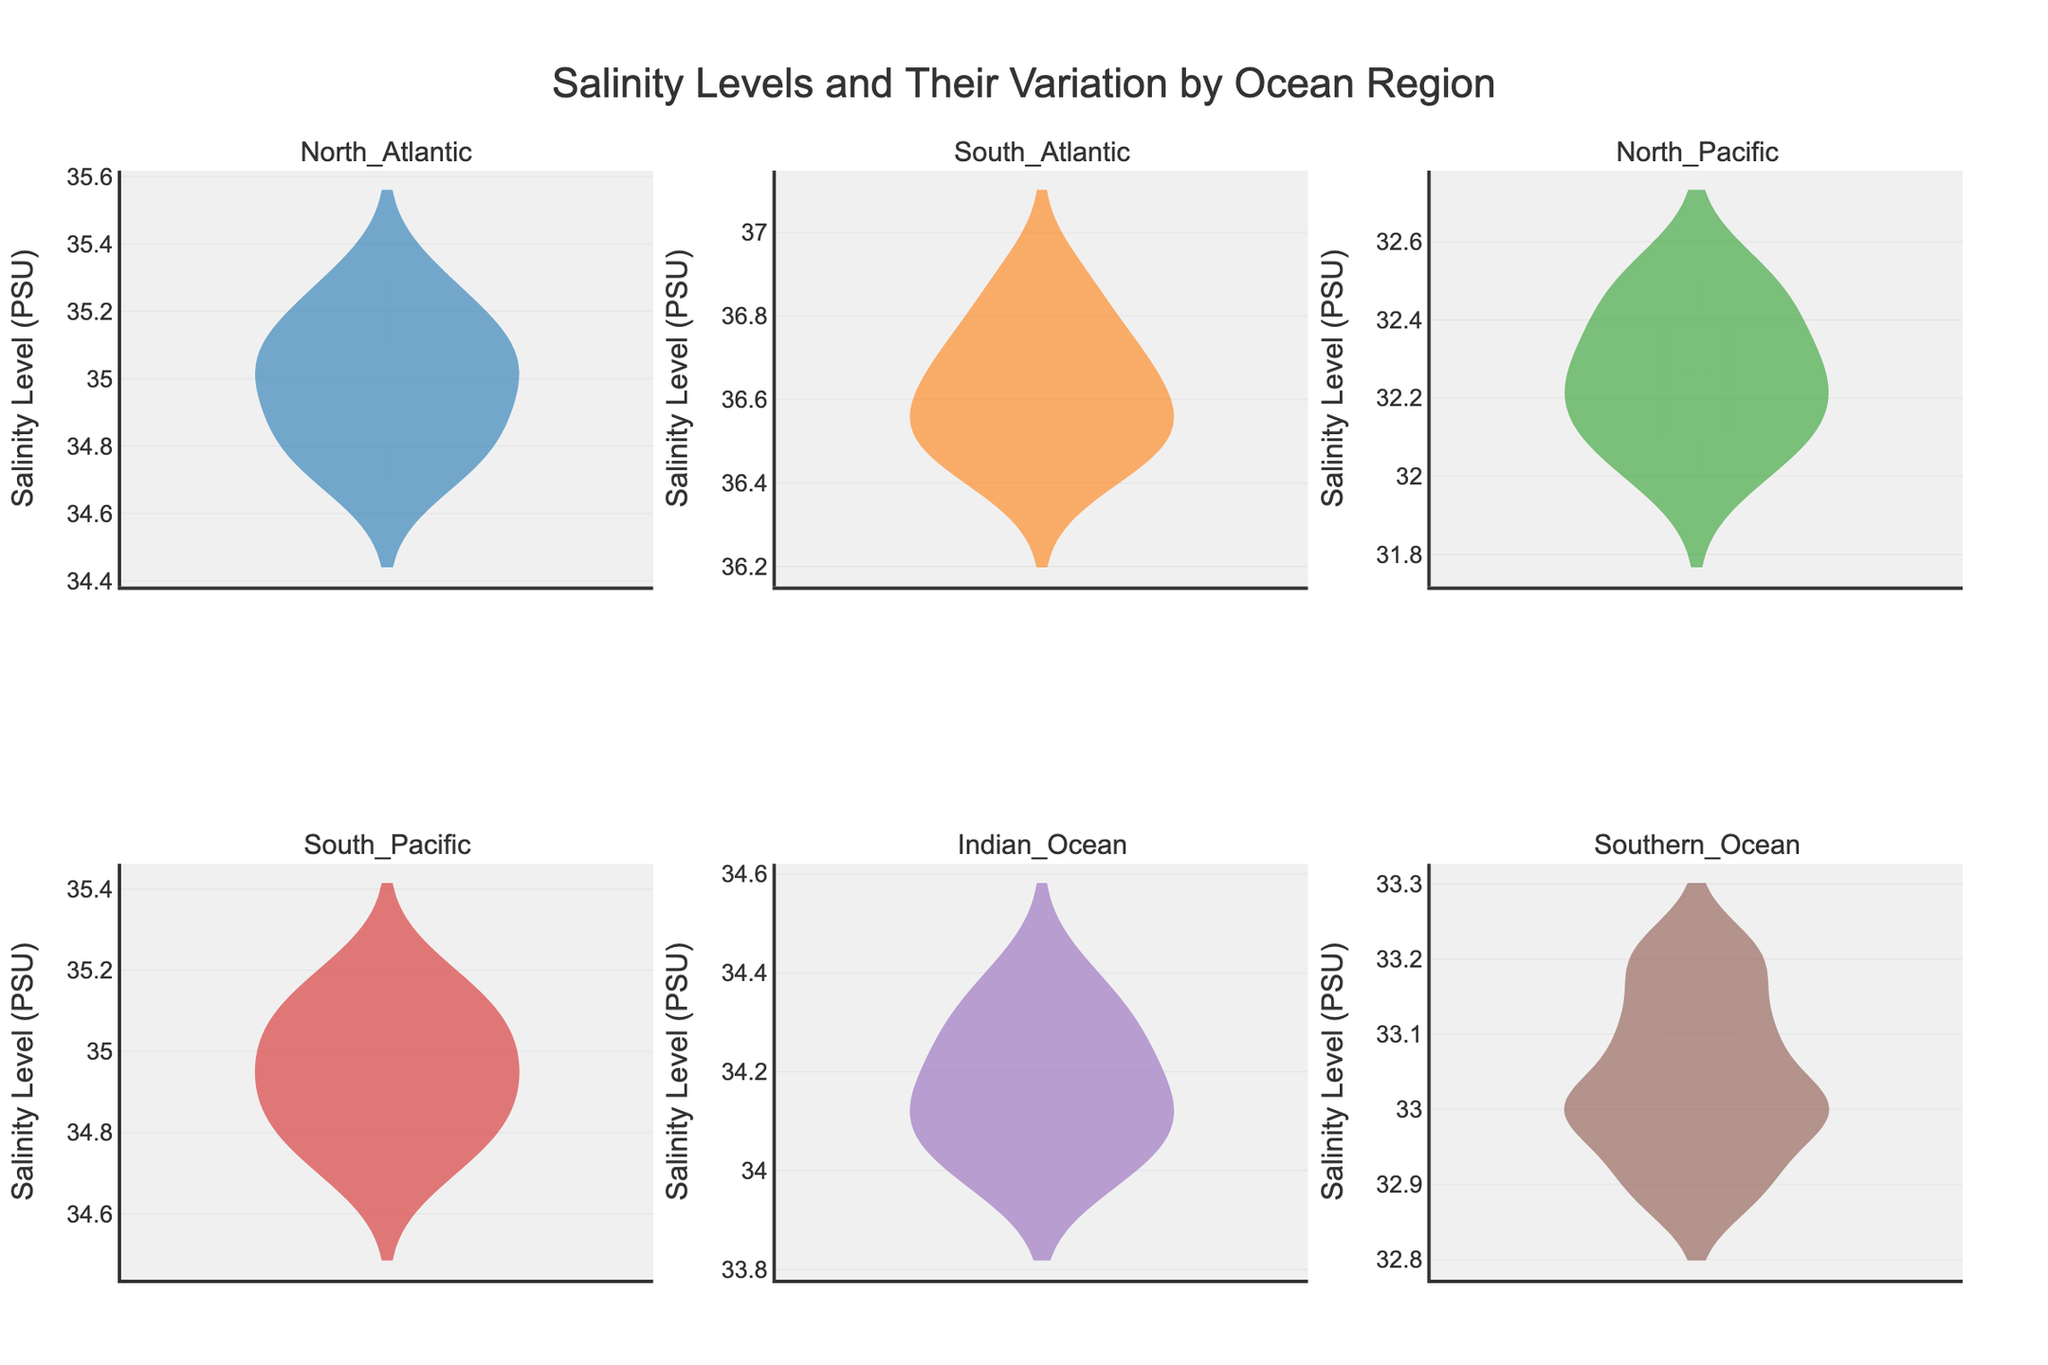What is the title of the figure? The title of the figure is present at the top, and it states the overall theme of the visualization.
Answer: Salinity Levels and Their Variation by Ocean Region How many ocean regions are displayed in the figure? Each subplot represents a unique ocean region, and there are a total of 5 subplots for the different ocean regions.
Answer: 6 Which ocean region has the salinity levels ranging between 32.0 and 32.5 PSU? By observing the salinity level range in each violin plot, the North Pacific subplot shows a salinity level range fitting this description.
Answer: North Pacific Which ocean region shows the highest variability in salinity levels? Variability is perceptible through the spread of the violin plot. Larger spreads indicate high variability. Observing the figure, the North Atlantic violin plot appears to have a noticeable spread but not the highest. The South Atlantic shows the highest spread.
Answer: South Atlantic What is the mean salinity level for the Indian Ocean region? The mean salinity can be inferred from the horizontal line inside the violin plot, indicating the mean line within the Indian Ocean subplot.
Answer: Approximately 34.2 Compare the salinity levels of the North Atlantic and Southern Ocean regions. Which one has higher values overall? By comparing the overall spread and central tendencies of the two violin plots, the North Atlantic has higher salinity levels compared to the Southern Ocean.
Answer: North Atlantic What is the range of salinity levels in the Southern Ocean region? The range can be identified from the minimum to the maximum extents of the violin plot for the Southern Ocean, which goes from approximately 32.9 to 33.2.
Answer: 32.9 to 33.2 Which ocean region has the most similar salinity range to the South Pacific region? By comparing the spread of the South Pacific violin plot with others, the North Atlantic also shows a range around 34.7 to 35.3.
Answer: North Atlantic What trend can you infer about the salinity levels as you compare ocean regions from North to South? Observing the violin plots, there is a general trend that Northern regions (North Atlantic, North Pacific) have higher salinity levels than the Southern regions (Southern Ocean). Further, moving towards equatorial regions like the Indian Ocean, the salinity levels are moderately high.
Answer: Salinity levels tend to be higher in northern oceans compared to southern oceans Which ocean region has the smallest range of salinity levels? The smallest range is indicated by the violin plot with the closest minimum and maximum salinity levels. The Southern Ocean has the smallest range based on its tight violin plot.
Answer: Southern Ocean 